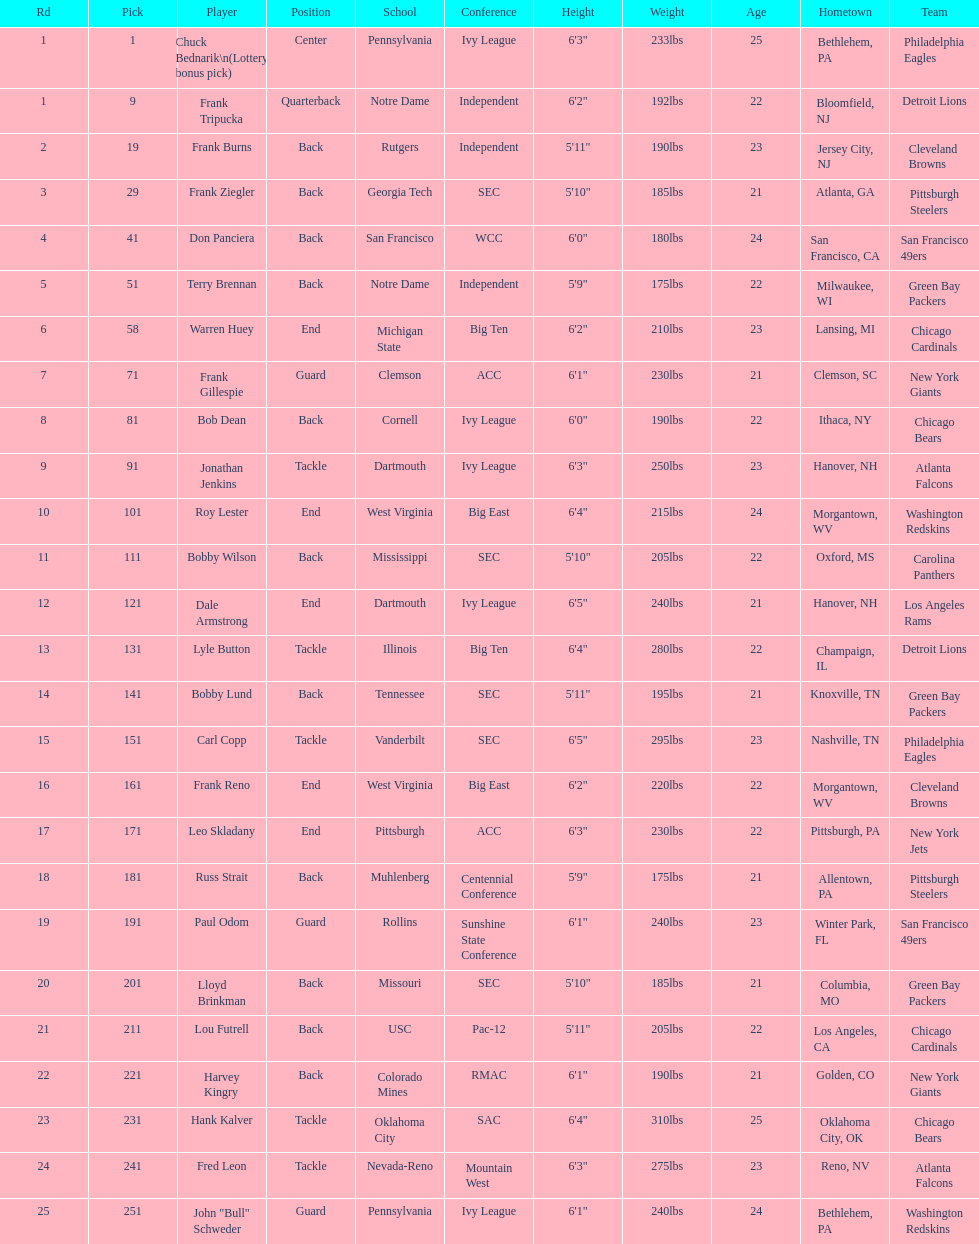Who has same position as frank gillespie? Paul Odom, John "Bull" Schweder. Parse the full table. {'header': ['Rd', 'Pick', 'Player', 'Position', 'School', 'Conference', 'Height', 'Weight', 'Age', 'Hometown', 'Team'], 'rows': [['1', '1', 'Chuck Bednarik\\n(Lottery bonus pick)', 'Center', 'Pennsylvania', 'Ivy League', '6\'3"', '233lbs', '25', 'Bethlehem, PA', 'Philadelphia Eagles'], ['1', '9', 'Frank Tripucka', 'Quarterback', 'Notre Dame', 'Independent', '6\'2"', '192lbs', '22', 'Bloomfield, NJ', 'Detroit Lions'], ['2', '19', 'Frank Burns', 'Back', 'Rutgers', 'Independent', '5\'11"', '190lbs', '23', 'Jersey City, NJ', 'Cleveland  Browns'], ['3', '29', 'Frank Ziegler', 'Back', 'Georgia Tech', 'SEC', '5\'10"', '185lbs', '21', 'Atlanta, GA', 'Pittsburgh Steelers'], ['4', '41', 'Don Panciera', 'Back', 'San Francisco', 'WCC', '6\'0"', '180lbs', '24', 'San Francisco, CA', 'San Francisco 49ers'], ['5', '51', 'Terry Brennan', 'Back', 'Notre Dame', 'Independent', '5\'9"', '175lbs', '22', 'Milwaukee, WI', 'Green Bay Packers'], ['6', '58', 'Warren Huey', 'End', 'Michigan State', 'Big Ten', '6\'2"', '210lbs', '23', 'Lansing, MI', 'Chicago Cardinals'], ['7', '71', 'Frank Gillespie', 'Guard', 'Clemson', 'ACC', '6\'1"', '230lbs', '21', 'Clemson, SC', 'New York Giants'], ['8', '81', 'Bob Dean', 'Back', 'Cornell', 'Ivy League', '6\'0"', '190lbs', '22', 'Ithaca, NY', 'Chicago Bears'], ['9', '91', 'Jonathan Jenkins', 'Tackle', 'Dartmouth', 'Ivy League', '6\'3"', '250lbs', '23', 'Hanover, NH', 'Atlanta Falcons'], ['10', '101', 'Roy Lester', 'End', 'West Virginia', 'Big East', '6\'4"', '215lbs', '24', 'Morgantown, WV', 'Washington Redskins'], ['11', '111', 'Bobby Wilson', 'Back', 'Mississippi', 'SEC', '5\'10"', '205lbs', '22', 'Oxford, MS', 'Carolina Panthers'], ['12', '121', 'Dale Armstrong', 'End', 'Dartmouth', 'Ivy League', '6\'5"', '240lbs', '21', 'Hanover, NH', 'Los Angeles Rams'], ['13', '131', 'Lyle Button', 'Tackle', 'Illinois', 'Big Ten', '6\'4"', '280lbs', '22', 'Champaign, IL', 'Detroit Lions'], ['14', '141', 'Bobby Lund', 'Back', 'Tennessee', 'SEC', '5\'11"', '195lbs', '21', 'Knoxville, TN', 'Green Bay Packers'], ['15', '151', 'Carl Copp', 'Tackle', 'Vanderbilt', 'SEC', '6\'5"', '295lbs', '23', 'Nashville, TN', 'Philadelphia Eagles'], ['16', '161', 'Frank Reno', 'End', 'West Virginia', 'Big East', '6\'2"', '220lbs', '22', 'Morgantown, WV', 'Cleveland Browns'], ['17', '171', 'Leo Skladany', 'End', 'Pittsburgh', 'ACC', '6\'3"', '230lbs', '22', 'Pittsburgh, PA', 'New York Jets'], ['18', '181', 'Russ Strait', 'Back', 'Muhlenberg', 'Centennial Conference', '5\'9"', '175lbs', '21', 'Allentown, PA', 'Pittsburgh Steelers'], ['19', '191', 'Paul Odom', 'Guard', 'Rollins', 'Sunshine State Conference', '6\'1"', '240lbs', '23', 'Winter Park, FL', 'San Francisco 49ers'], ['20', '201', 'Lloyd Brinkman', 'Back', 'Missouri', 'SEC', '5\'10"', '185lbs', '21', 'Columbia, MO', 'Green Bay Packers'], ['21', '211', 'Lou Futrell', 'Back', 'USC', 'Pac-12', '5\'11"', '205lbs', '22', 'Los Angeles, CA', 'Chicago Cardinals'], ['22', '221', 'Harvey Kingry', 'Back', 'Colorado Mines', 'RMAC', '6\'1"', '190lbs', '21', 'Golden, CO', 'New York Giants'], ['23', '231', 'Hank Kalver', 'Tackle', 'Oklahoma City', 'SAC', '6\'4"', '310lbs', '25', 'Oklahoma City, OK', 'Chicago Bears'], ['24', '241', 'Fred Leon', 'Tackle', 'Nevada-Reno', 'Mountain West', '6\'3"', '275lbs', '23', 'Reno, NV', 'Atlanta Falcons'], ['25', '251', 'John "Bull" Schweder', 'Guard', 'Pennsylvania', 'Ivy League', '6\'1"', '240lbs', '24', 'Bethlehem, PA', 'Washington Redskins']]} 